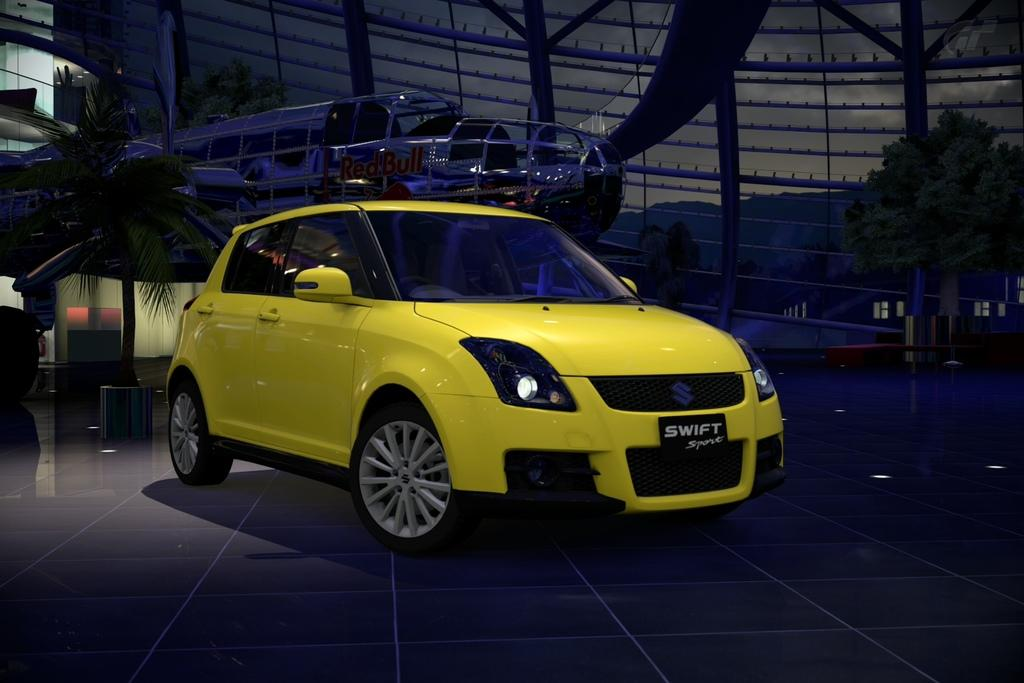What color is the car in the image? The car in the image is yellow. Where is the car located in the image? The car is on the floor in the image. What can be seen in the background of the image? There are trees visible in the background of the image. What else is on the floor in the background of the image? There are other objects on the floor in the background of the image. How many clams are sitting on the car in the image? There are no clams present in the image; it features a yellow car on the floor with trees in the background. What type of change can be seen happening to the car in the image? There is no change happening to the car in the image; it is stationary on the floor. 